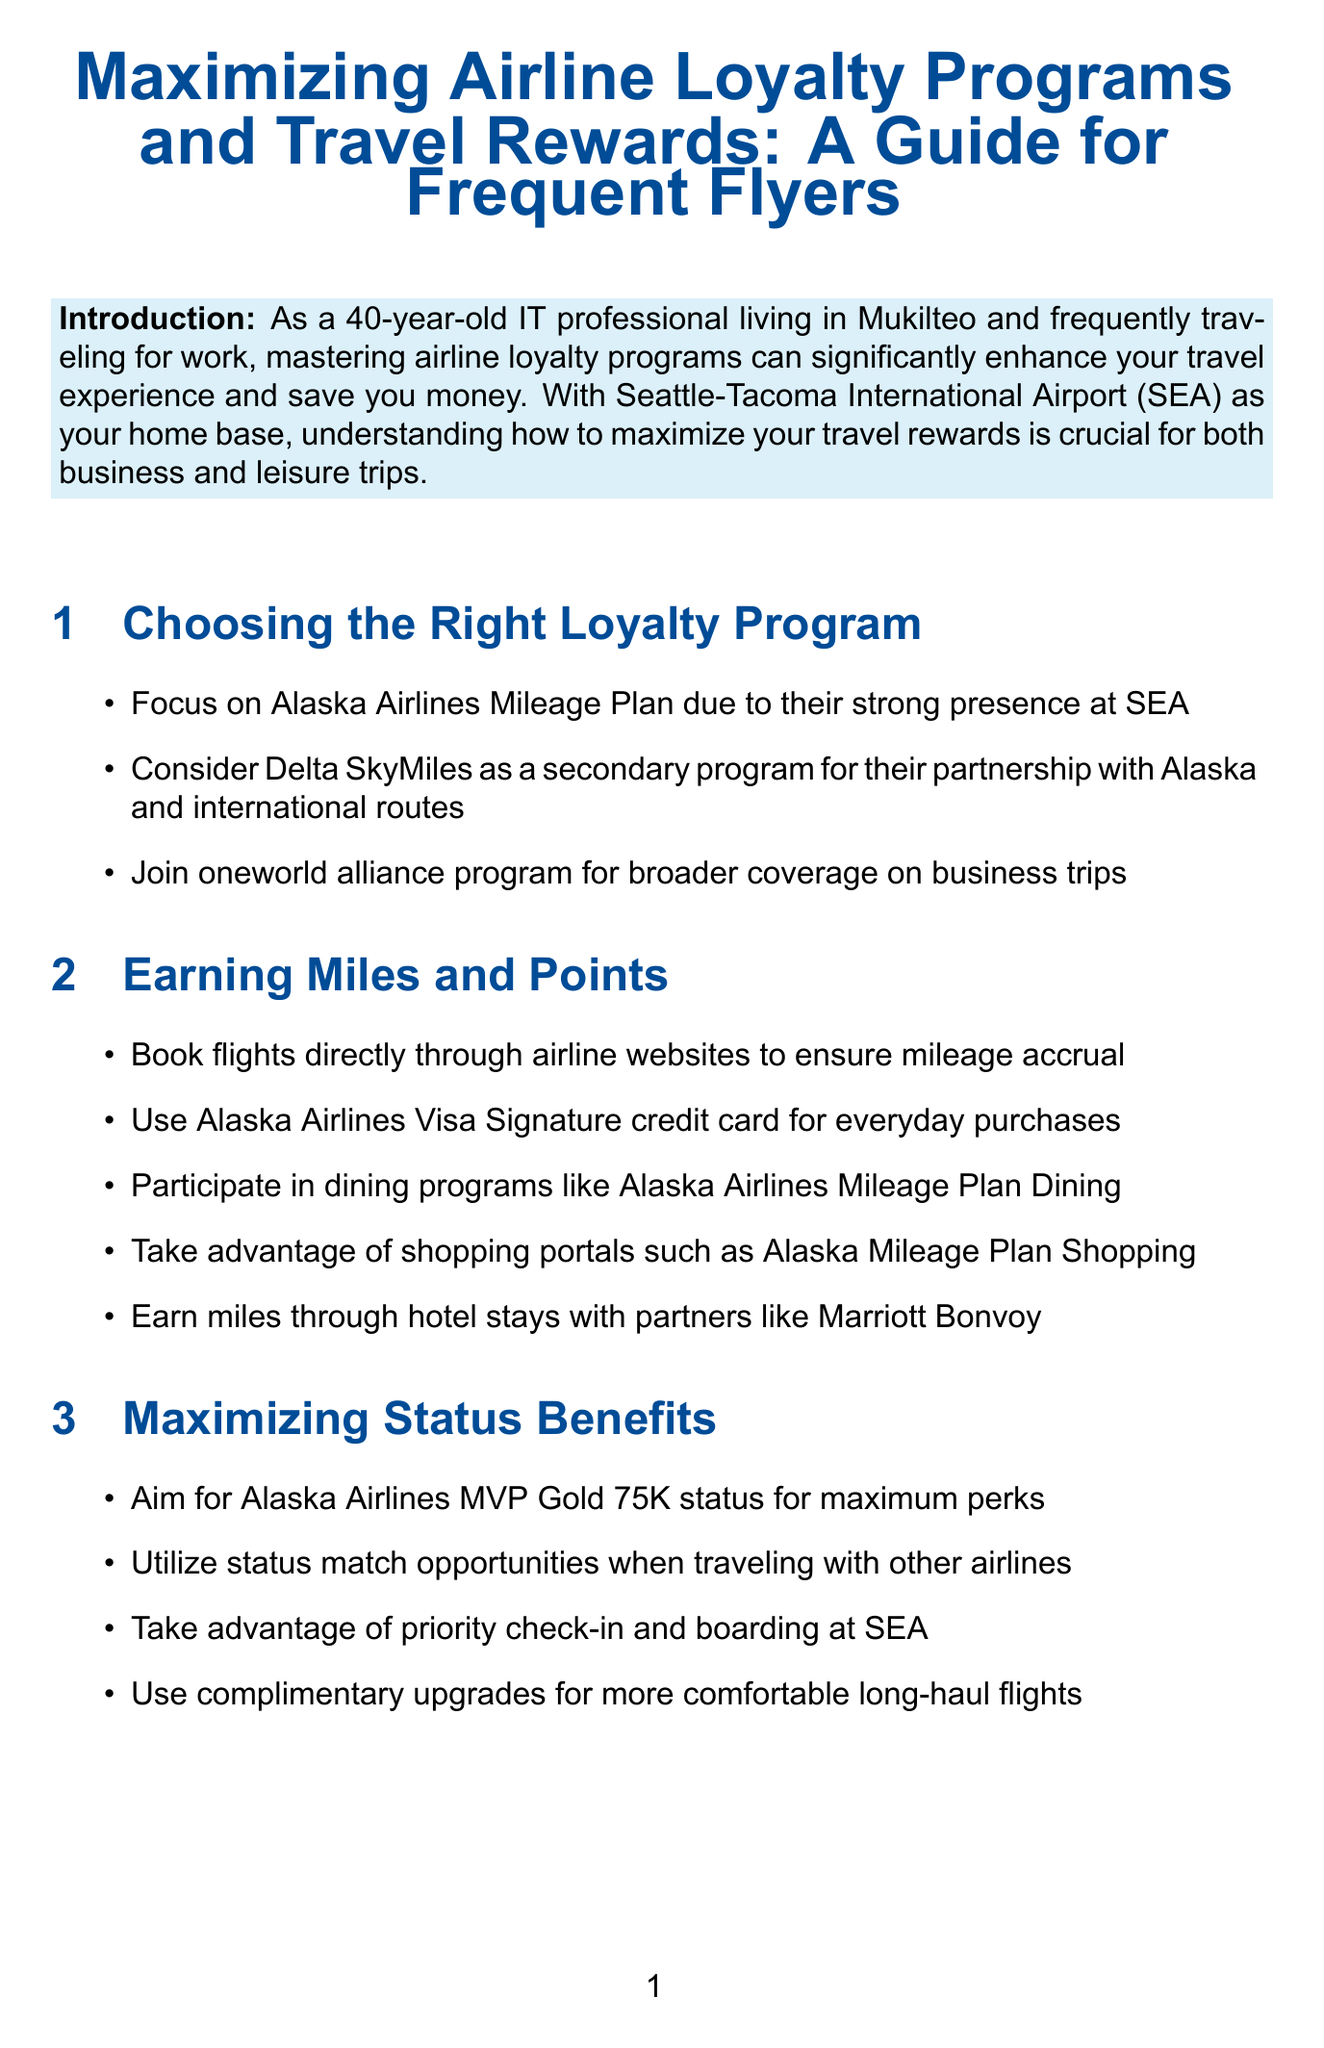What is the main focus of the guide? The guide aims to help individuals master airline loyalty programs to enhance their travel experience and save money.
Answer: mastering airline loyalty programs What is the suggested primary loyalty program? The document recommends this program due to its strong presence at Seattle-Tacoma International Airport.
Answer: Alaska Airlines Mileage Plan What credit card is advised for everyday purchases? The guide suggests using a specific credit card to earn miles on daily spending.
Answer: Alaska Airlines Visa Signature credit card What status is recommended for maximum perks? The text advises aiming for a specific elite status level within the airline's program.
Answer: MVP Gold 75K status Which program should you follow for travel updates? This blog is recommended for frequent flyers to stay informed about loyalty programs.
Answer: The Points Guy How can you enhance your airport experience? The document mentions a program that expedites security and customs processing.
Answer: TSA PreCheck and Global Entry What should be reviewed for optimization? The conclusion emphasizes reviewing this aspect to maximize travel rewards.
Answer: current loyalty program memberships What is a benefit of the Alaska Airlines Visa Signature card? The document lists one of the significant perks of having this card.
Answer: free checked bags What type of travel does the guide suggest you can combine? The document provides a suggestion for mixing personal life with business-related travel.
Answer: personal travel 